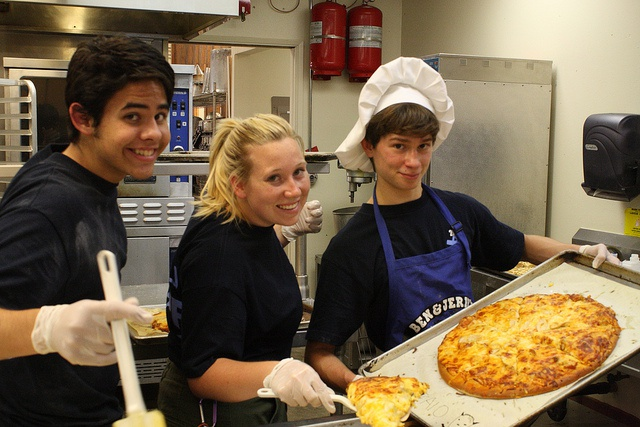Describe the objects in this image and their specific colors. I can see people in maroon, black, tan, and brown tones, people in maroon, black, navy, ivory, and brown tones, people in maroon, black, brown, and tan tones, pizza in maroon, orange, gold, and red tones, and oven in maroon, black, navy, darkblue, and darkgray tones in this image. 